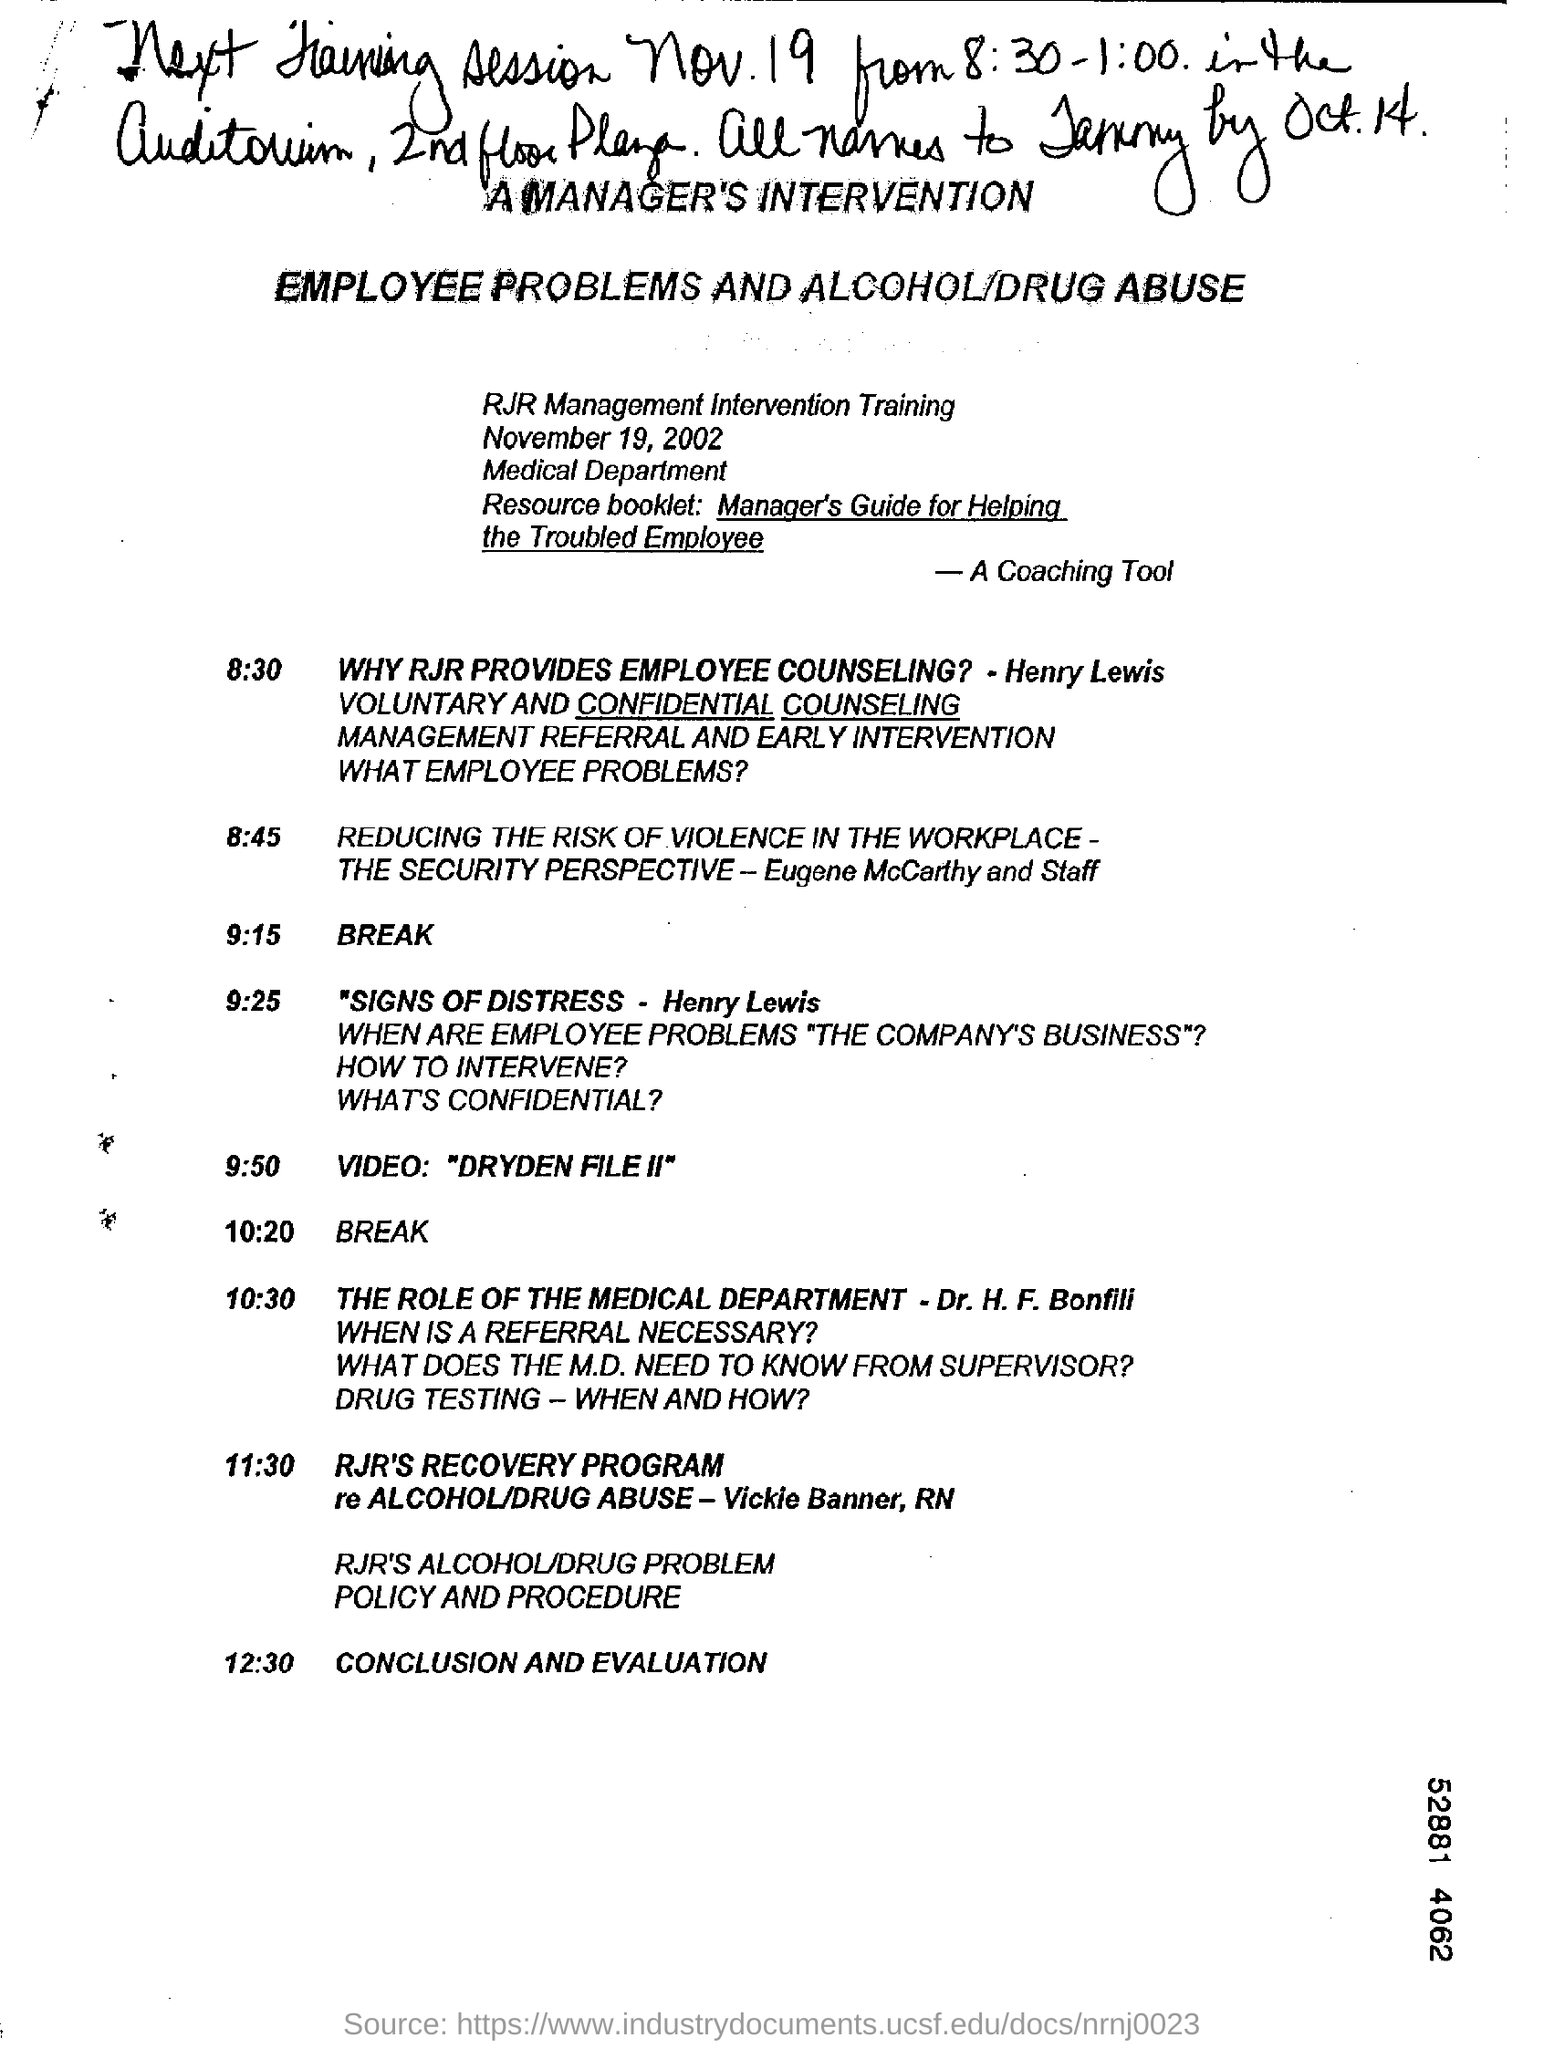Give some essential details in this illustration. The video referred to in the document is "DRYDEN FILE II". The document mentions the Medical Department. The intervention training was mentioned on November 19, 2002. The main topics to be addressed in the training are employee problems and alcohol/drug abuse. 